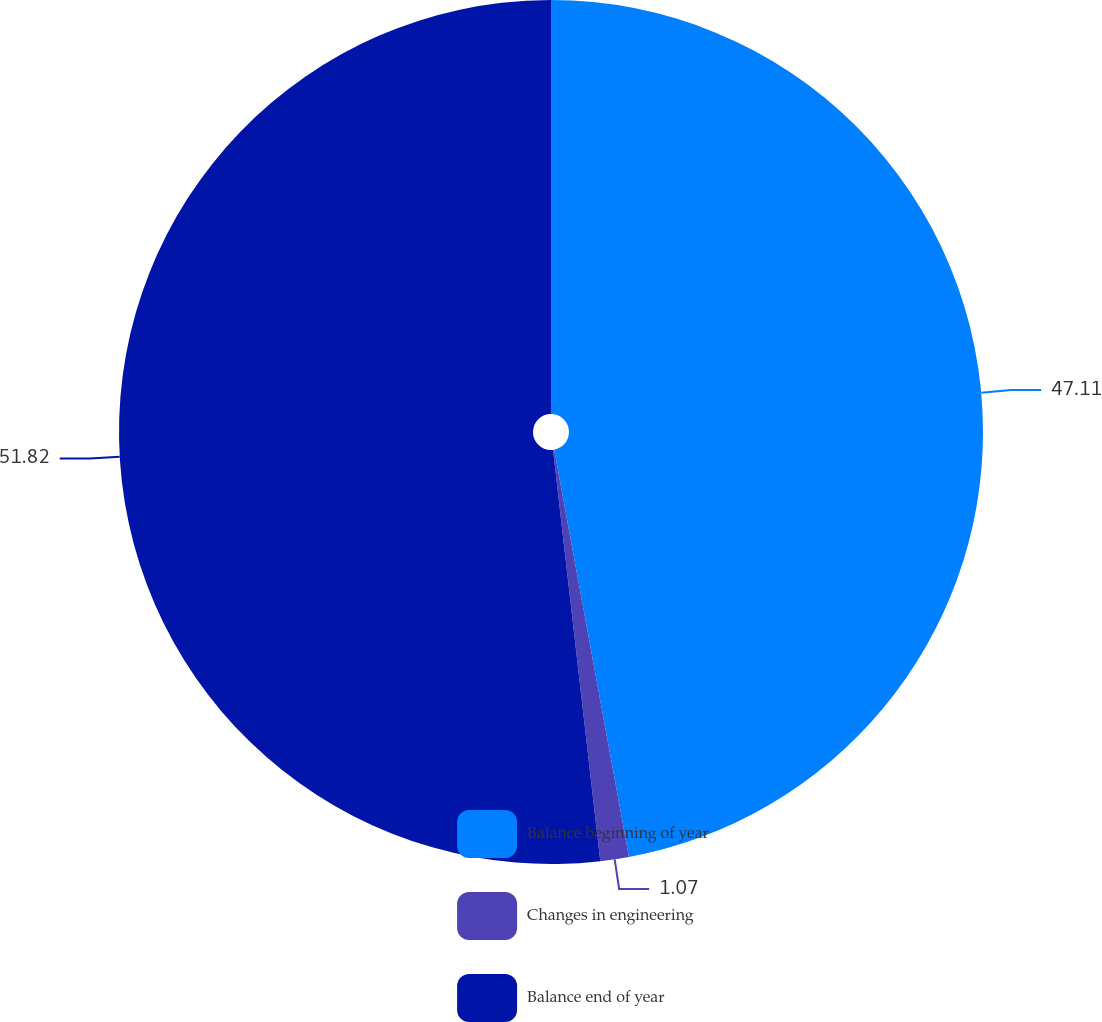Convert chart to OTSL. <chart><loc_0><loc_0><loc_500><loc_500><pie_chart><fcel>Balance beginning of year<fcel>Changes in engineering<fcel>Balance end of year<nl><fcel>47.11%<fcel>1.07%<fcel>51.82%<nl></chart> 